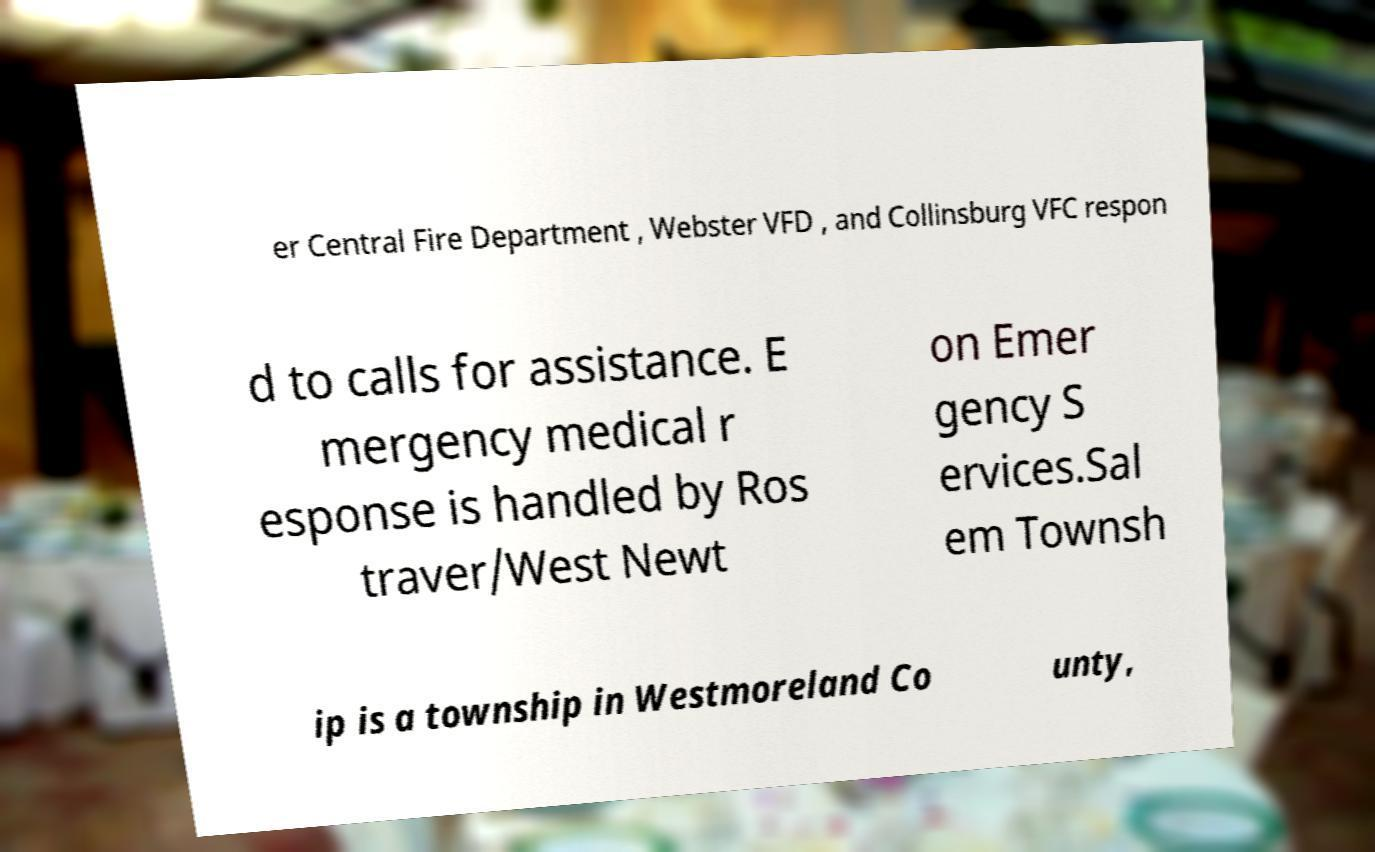What messages or text are displayed in this image? I need them in a readable, typed format. er Central Fire Department , Webster VFD , and Collinsburg VFC respon d to calls for assistance. E mergency medical r esponse is handled by Ros traver/West Newt on Emer gency S ervices.Sal em Townsh ip is a township in Westmoreland Co unty, 